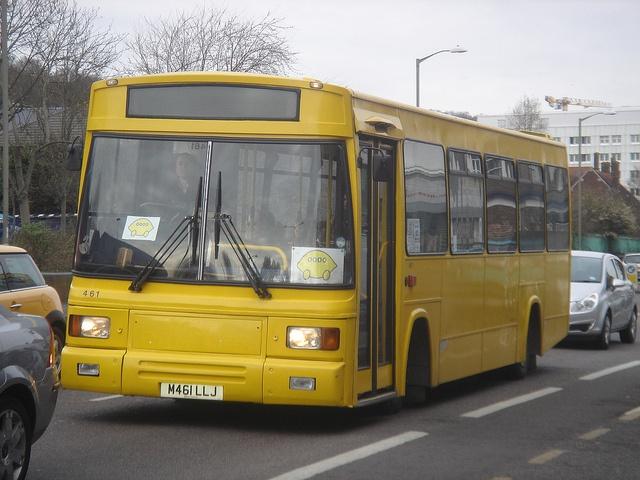Describe the objects in this image and their specific colors. I can see bus in gray, olive, and black tones, car in gray and black tones, car in gray, darkgray, lavender, and black tones, car in gray, black, olive, and darkgray tones, and people in gray tones in this image. 